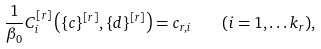<formula> <loc_0><loc_0><loc_500><loc_500>\frac { 1 } { \beta _ { 0 } } C _ { i } ^ { [ r ] } \left ( \{ c \} ^ { [ r ] } , \{ d \} ^ { [ r ] } \right ) = c _ { r , i } \quad ( i = 1 , \dots k _ { r } ) ,</formula> 